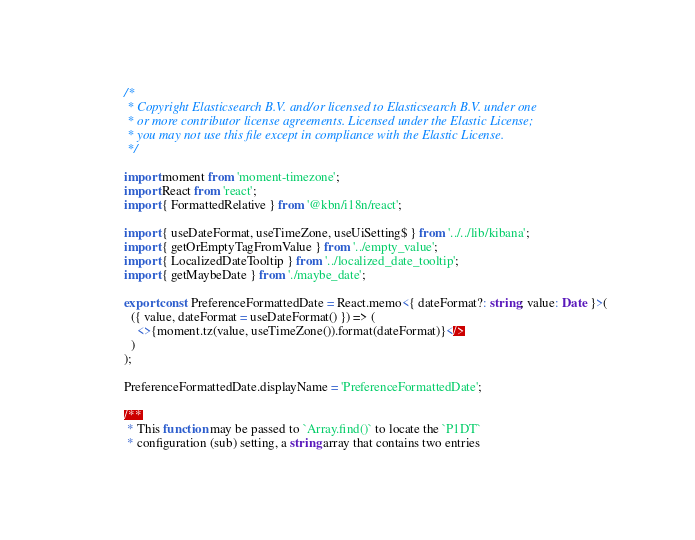<code> <loc_0><loc_0><loc_500><loc_500><_TypeScript_>/*
 * Copyright Elasticsearch B.V. and/or licensed to Elasticsearch B.V. under one
 * or more contributor license agreements. Licensed under the Elastic License;
 * you may not use this file except in compliance with the Elastic License.
 */

import moment from 'moment-timezone';
import React from 'react';
import { FormattedRelative } from '@kbn/i18n/react';

import { useDateFormat, useTimeZone, useUiSetting$ } from '../../lib/kibana';
import { getOrEmptyTagFromValue } from '../empty_value';
import { LocalizedDateTooltip } from '../localized_date_tooltip';
import { getMaybeDate } from './maybe_date';

export const PreferenceFormattedDate = React.memo<{ dateFormat?: string; value: Date }>(
  ({ value, dateFormat = useDateFormat() }) => (
    <>{moment.tz(value, useTimeZone()).format(dateFormat)}</>
  )
);

PreferenceFormattedDate.displayName = 'PreferenceFormattedDate';

/**
 * This function may be passed to `Array.find()` to locate the `P1DT`
 * configuration (sub) setting, a string array that contains two entries</code> 